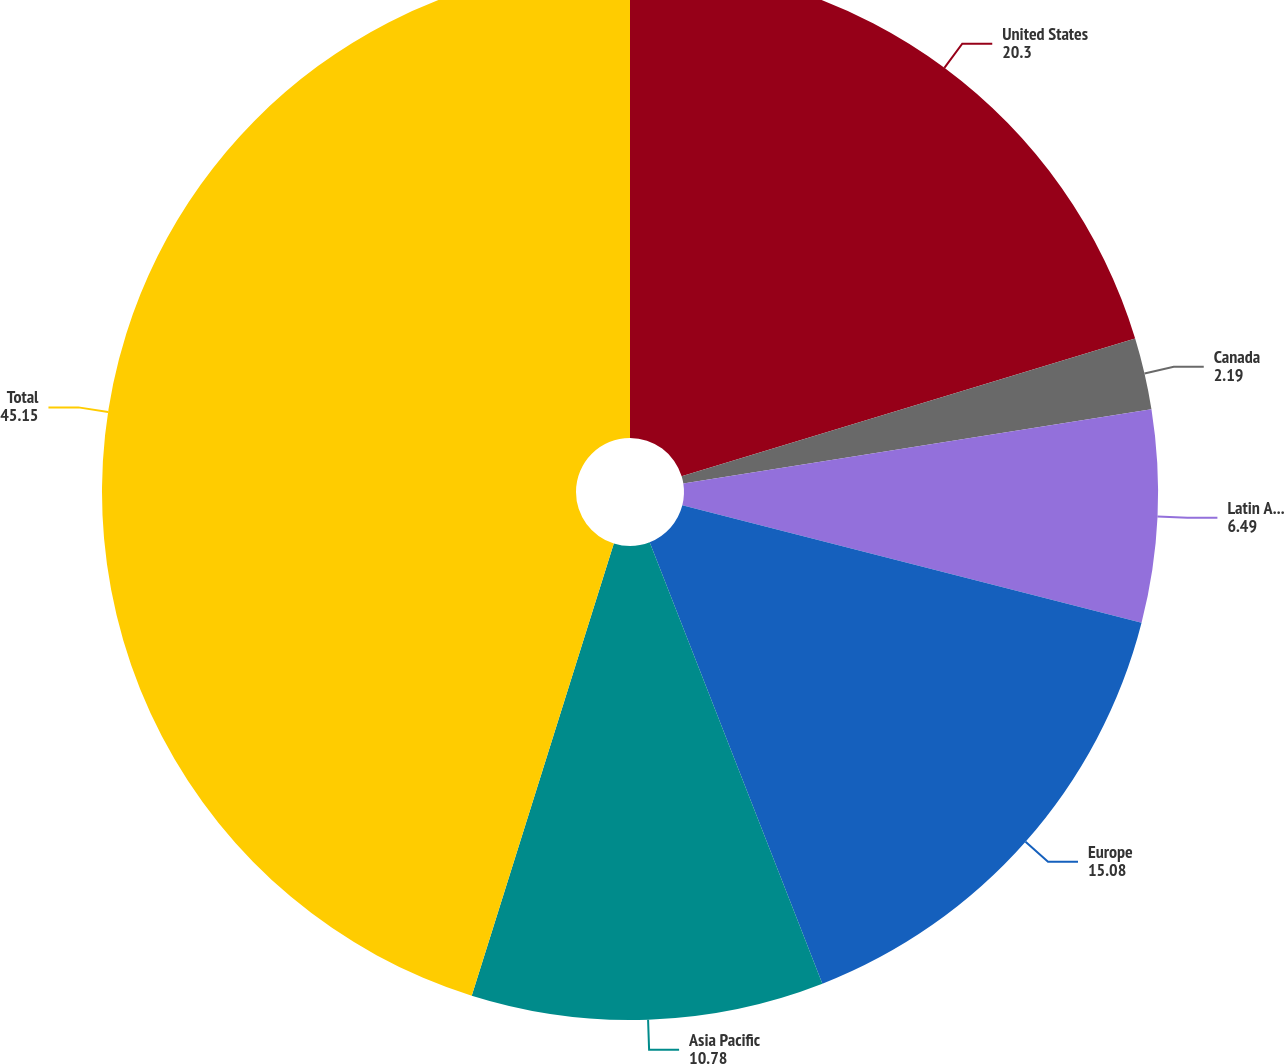Convert chart. <chart><loc_0><loc_0><loc_500><loc_500><pie_chart><fcel>United States<fcel>Canada<fcel>Latin America<fcel>Europe<fcel>Asia Pacific<fcel>Total<nl><fcel>20.3%<fcel>2.19%<fcel>6.49%<fcel>15.08%<fcel>10.78%<fcel>45.15%<nl></chart> 